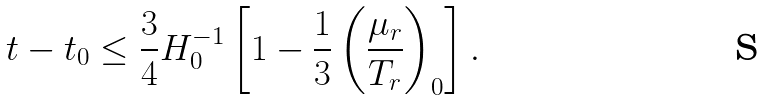Convert formula to latex. <formula><loc_0><loc_0><loc_500><loc_500>t - t _ { 0 } \leq \frac { 3 } { 4 } H _ { 0 } ^ { - 1 } \left [ 1 - \frac { 1 } { 3 } \left ( \frac { \mu _ { r } } { T _ { r } } \right ) _ { 0 } \right ] .</formula> 